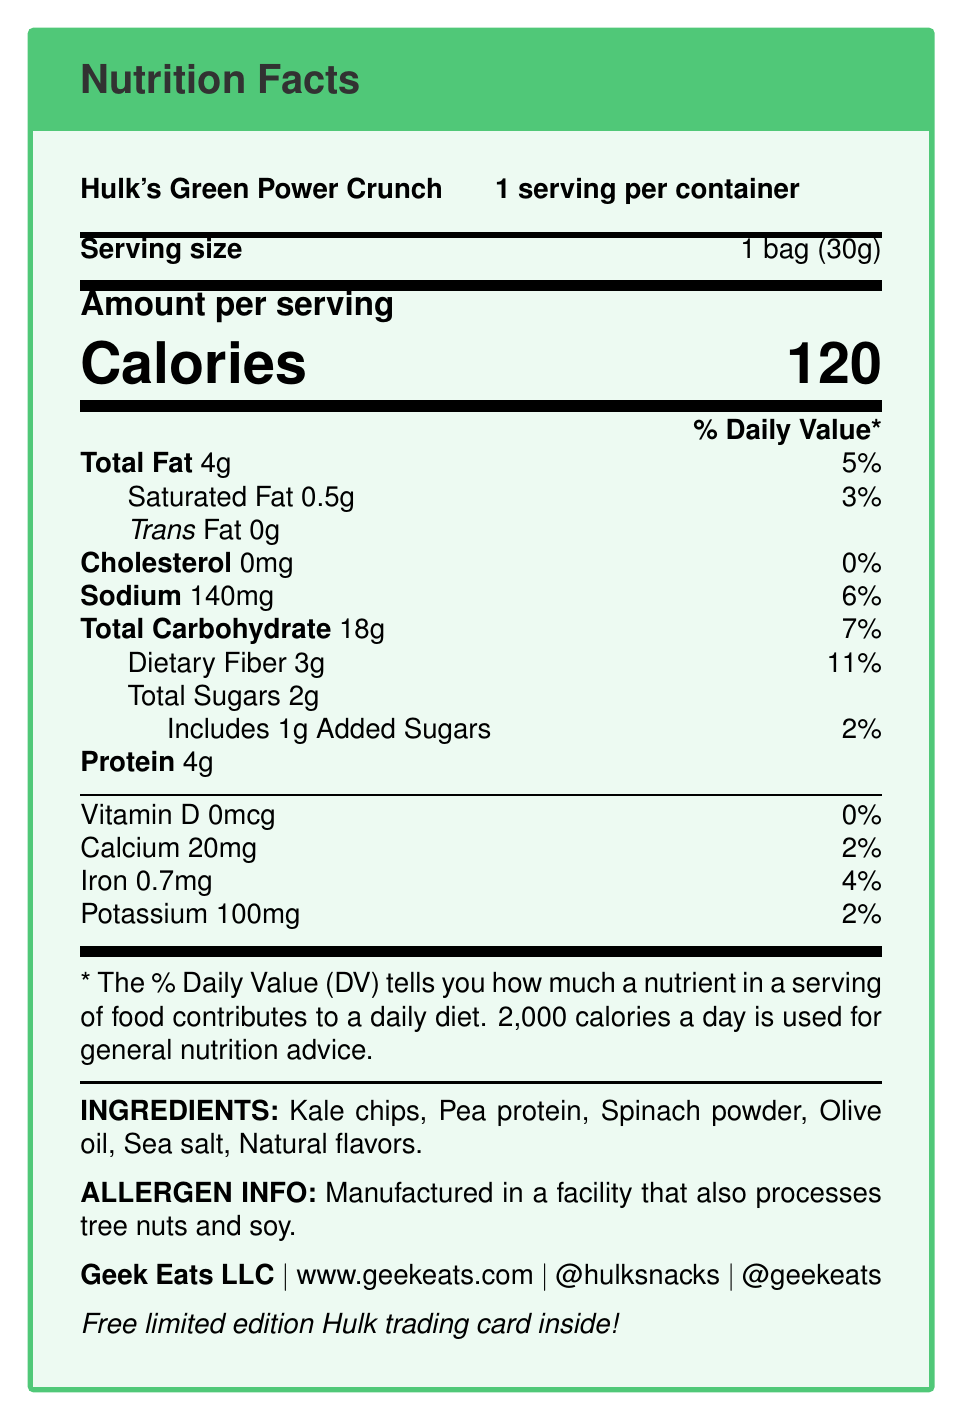what is the serving size? The serving size is explicitly mentioned in the document as "1 bag (30g)".
Answer: 1 bag (30g) how many calories are in one serving? The document states there are 120 calories per serving.
Answer: 120 how much dietary fiber does one serving contain? The dietary fiber amount per serving is listed as 3g.
Answer: 3g what company manufactures Hulk's Green Power Crunch? The manufacturer is noted as Geek Eats LLC in the document.
Answer: Geek Eats LLC what is the main branding image on the packaging? The packaging design is described as featuring a Green Hulk fist crushing kale chips.
Answer: Green Hulk fist crushing kale chips which nutrient has the highest % Daily Value? The dietary fiber has a daily value of 11%, which is the highest among the listed nutrients.
Answer: Dietary Fiber how many servings are in one container? There is one serving per container, as specified in the document.
Answer: 1 what is the amount of added sugars per serving? The document states that there is 1g of added sugars per serving.
Answer: 1g what is the official website for Geek Eats LLC? The official website is listed as www.geekeats.com.
Answer: www.geekeats.com what promotional item comes with each package? The document mentions a free limited edition Hulk trading card inside each package.
Answer: Free limited edition Hulk trading card which social media platforms can you follow for updates? A. Facebook B. Instagram C. Twitter D. LinkedIn The document mentions Instagram (@hulksnacks) and Twitter (@geekeats) as the social media platforms.
Answer: B, C which of the following ingredients is NOT listed? A. Spinach powder B. Olive oil C. Tree nuts D. Kale chips Tree nuts are not listed as an ingredient; they are mentioned in the allergen info as being processed in the same facility.
Answer: C does the product have any trans fat? The trans fat content is listed as 0g, indicating there is no trans fat.
Answer: No is this snack suitable for someone looking to increase their protein intake? With 4g of protein per serving, it can be considered a suitable choice for someone looking to increase their protein intake.
Answer: Yes describe the main idea of this document. This summary captures the product's identity, nutritional details, branding, and target audience based on the information in the document.
Answer: Hulk's Green Power Crunch is a healthy snack packaged with pop culture-themed Marvel Superheroes branding, emphasizing its nutritional value and targeting health-conscious comic book fans. how many different distribution channels are mentioned? The document lists three distribution channels: comic book stores, comic conventions, and online retailers.
Answer: 3 what are the storage instructions for this product? The storage instructions specify storing the product in a cool, dry place away from direct sunlight.
Answer: Store in a cool, dry place away from direct sunlight are there any allergens in this product? While the product itself does not list nuts or soy as ingredients, the allergen information states it is made in a facility that also processes tree nuts and soy.
Answer: Yes, it is manufactured in a facility that processes tree nuts and soy how long is the shelf life of Hulk's Green Power Crunch? The document mentions a shelf life of 6 months for the product.
Answer: 6 months what is the exact amount of iron per serving? The iron content is detailed as 0.7mg per serving.
Answer: 0.7mg what other snacks does Geek Eats LLC manufacture? The document focuses solely on Hulk's Green Power Crunch and does not provide information about other snacks manufactured by Geek Eats LLC.
Answer: Not enough information 